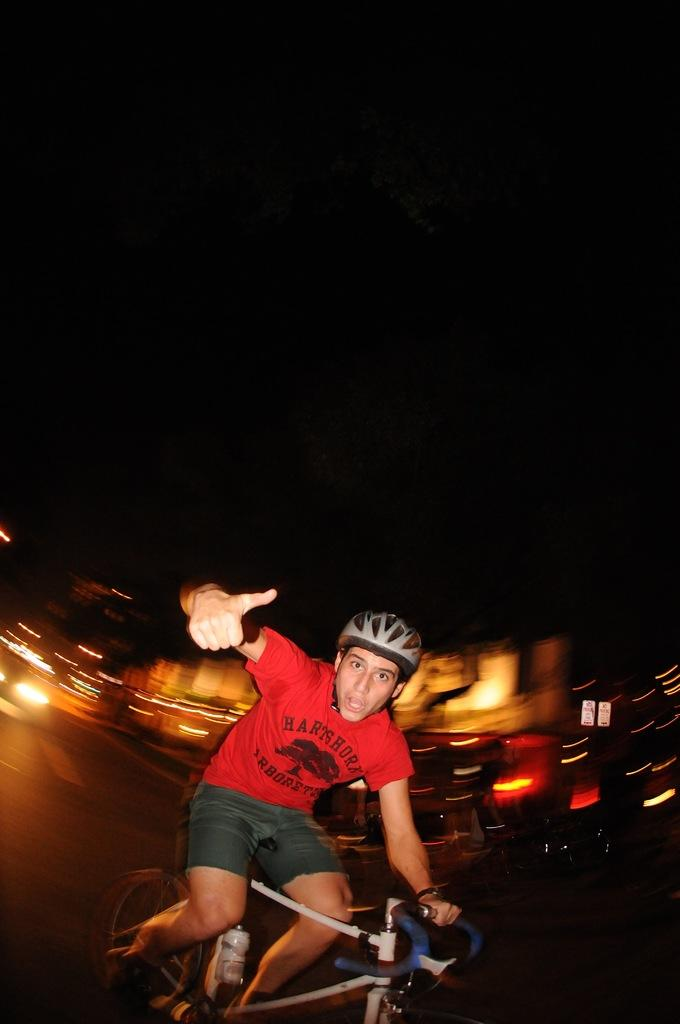Who is the main subject in the image? There is a man in the image. What is the man wearing on his head? The man is wearing a helmet. What color is the man's t-shirt? The man is wearing a red t-shirt. What activity is the man engaged in? The man is riding a bicycle. What type of lamp is hanging from the man's handlebars in the image? There is no lamp present on the man's bicycle in the image. 